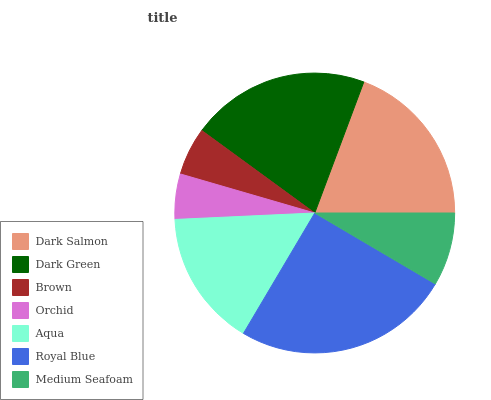Is Orchid the minimum?
Answer yes or no. Yes. Is Royal Blue the maximum?
Answer yes or no. Yes. Is Dark Green the minimum?
Answer yes or no. No. Is Dark Green the maximum?
Answer yes or no. No. Is Dark Green greater than Dark Salmon?
Answer yes or no. Yes. Is Dark Salmon less than Dark Green?
Answer yes or no. Yes. Is Dark Salmon greater than Dark Green?
Answer yes or no. No. Is Dark Green less than Dark Salmon?
Answer yes or no. No. Is Aqua the high median?
Answer yes or no. Yes. Is Aqua the low median?
Answer yes or no. Yes. Is Medium Seafoam the high median?
Answer yes or no. No. Is Medium Seafoam the low median?
Answer yes or no. No. 